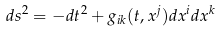<formula> <loc_0><loc_0><loc_500><loc_500>d s ^ { 2 } = - d t ^ { 2 } + g _ { i k } ( t , x ^ { j } ) d x ^ { i } d x ^ { k }</formula> 